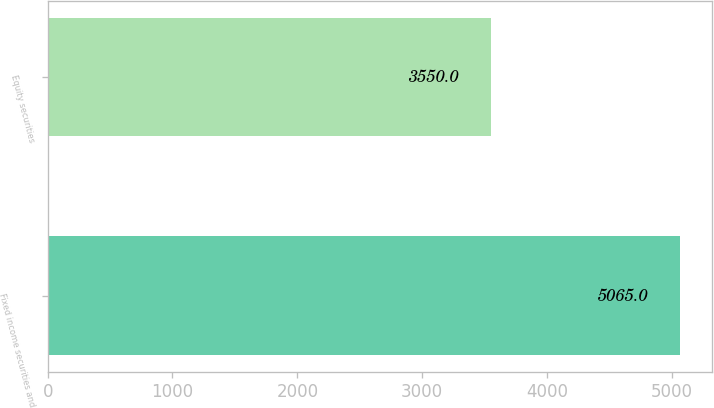<chart> <loc_0><loc_0><loc_500><loc_500><bar_chart><fcel>Fixed income securities and<fcel>Equity securities<nl><fcel>5065<fcel>3550<nl></chart> 